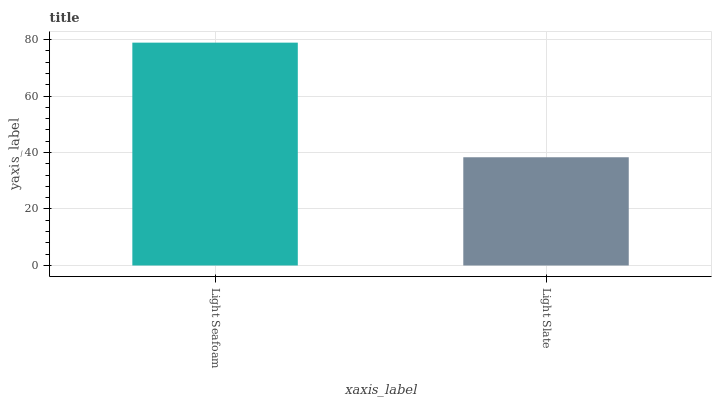Is Light Slate the minimum?
Answer yes or no. Yes. Is Light Seafoam the maximum?
Answer yes or no. Yes. Is Light Slate the maximum?
Answer yes or no. No. Is Light Seafoam greater than Light Slate?
Answer yes or no. Yes. Is Light Slate less than Light Seafoam?
Answer yes or no. Yes. Is Light Slate greater than Light Seafoam?
Answer yes or no. No. Is Light Seafoam less than Light Slate?
Answer yes or no. No. Is Light Seafoam the high median?
Answer yes or no. Yes. Is Light Slate the low median?
Answer yes or no. Yes. Is Light Slate the high median?
Answer yes or no. No. Is Light Seafoam the low median?
Answer yes or no. No. 